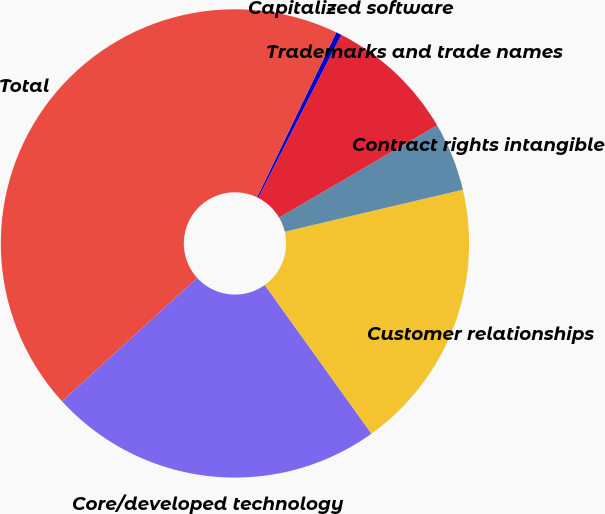Convert chart to OTSL. <chart><loc_0><loc_0><loc_500><loc_500><pie_chart><fcel>Core/developed technology<fcel>Customer relationships<fcel>Contract rights intangible<fcel>Trademarks and trade names<fcel>Capitalized software<fcel>Total<nl><fcel>23.13%<fcel>18.78%<fcel>4.73%<fcel>9.08%<fcel>0.38%<fcel>43.9%<nl></chart> 